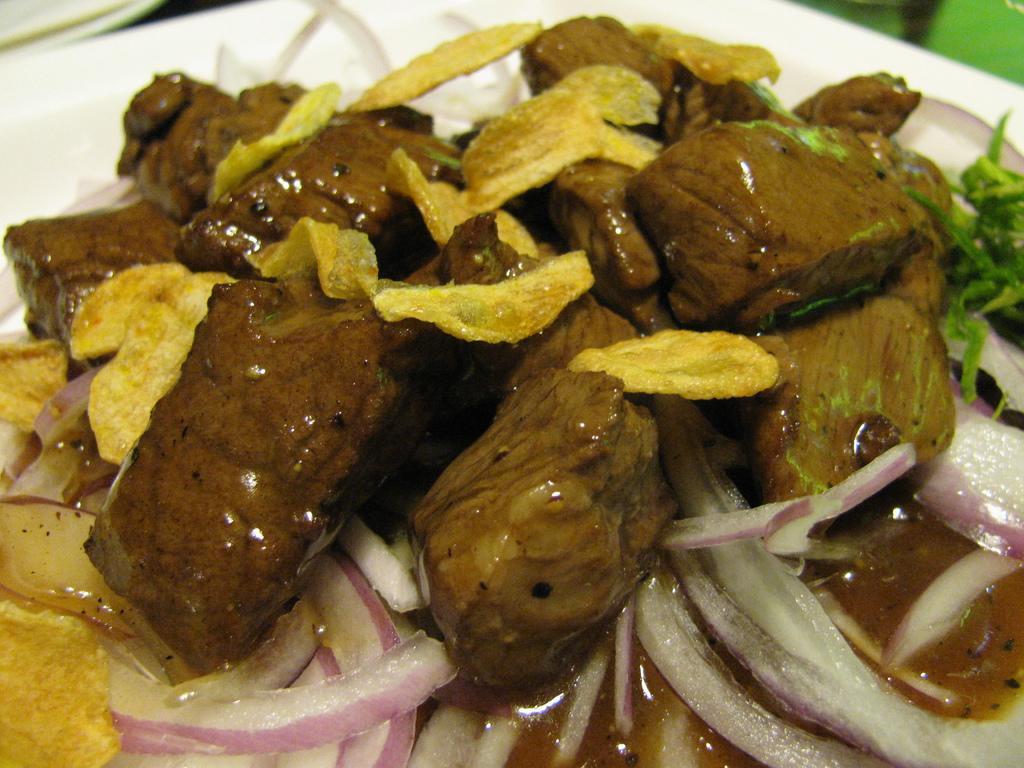Can you describe this image briefly? In this image we can see pieces of chicken dipped in a sauce, on top of the pieces of chicken there are crisps and onion on a plate. 